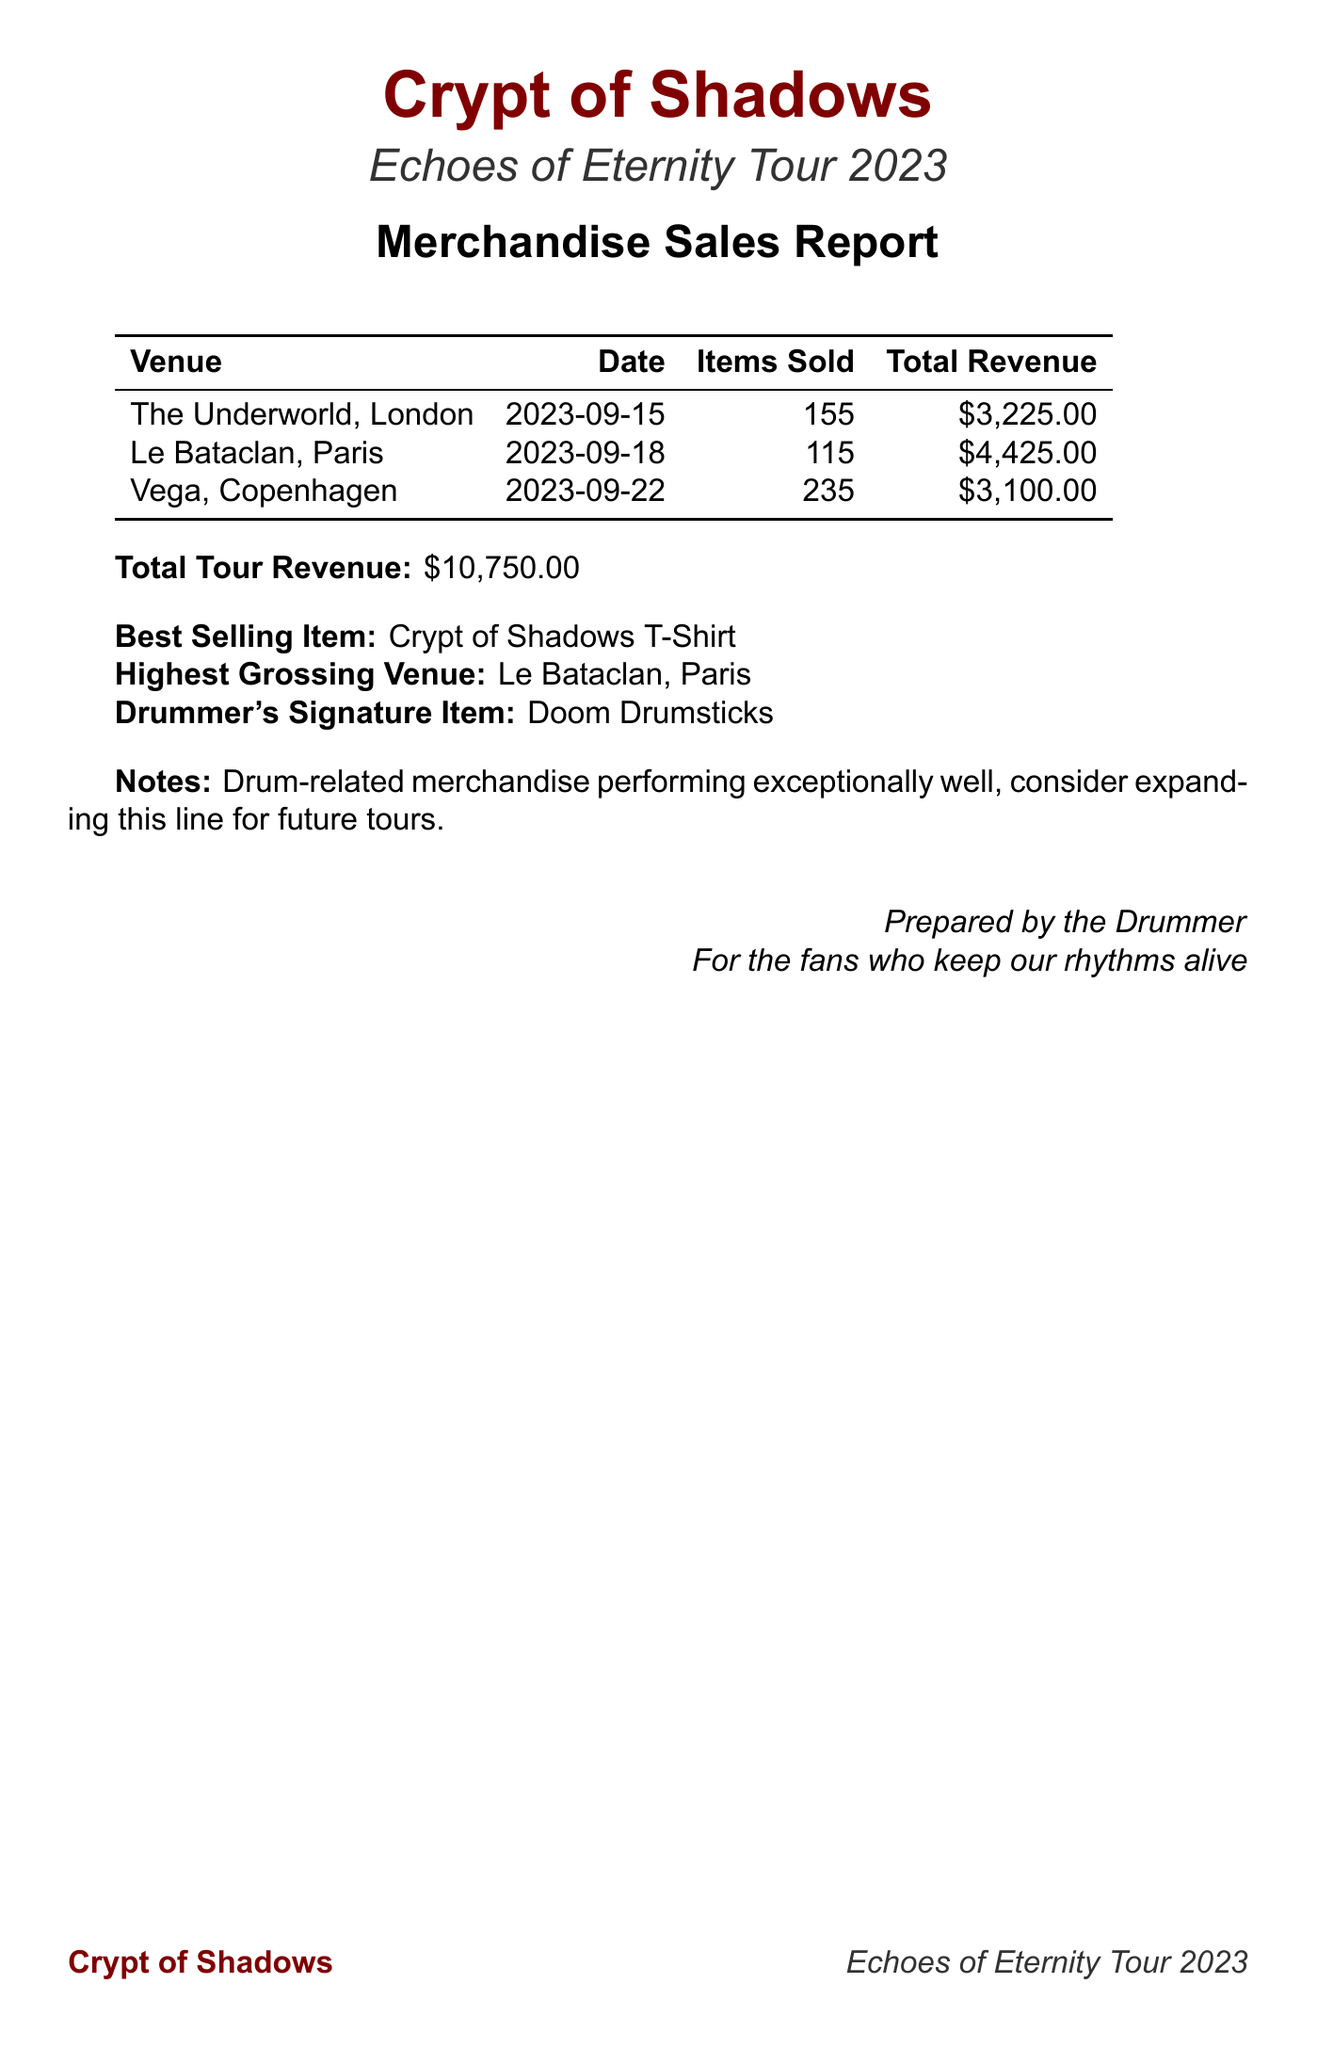What is the total tour revenue? The total tour revenue is listed at the bottom of the document, showing the total amount earned from merchandise sales throughout the tour.
Answer: $10,750.00 What is the date of the concert at Le Bataclan? The specific date of the concert at Le Bataclan is mentioned alongside the venue details in the sales report.
Answer: 2023-09-18 What item sold the most units overall? The best-selling item is highlighted in the report as the item that generated the highest sales across all venues.
Answer: Crypt of Shadows T-Shirt Which venue had the highest sales revenue? The report identifies the venue that generated the most revenue from merchandise sales during the tour.
Answer: Le Bataclan, Paris How many Drumstick Keychains were sold at Vega? The sales report provides the quantity sold for each item under the items sold section for Vega.
Answer: 100 